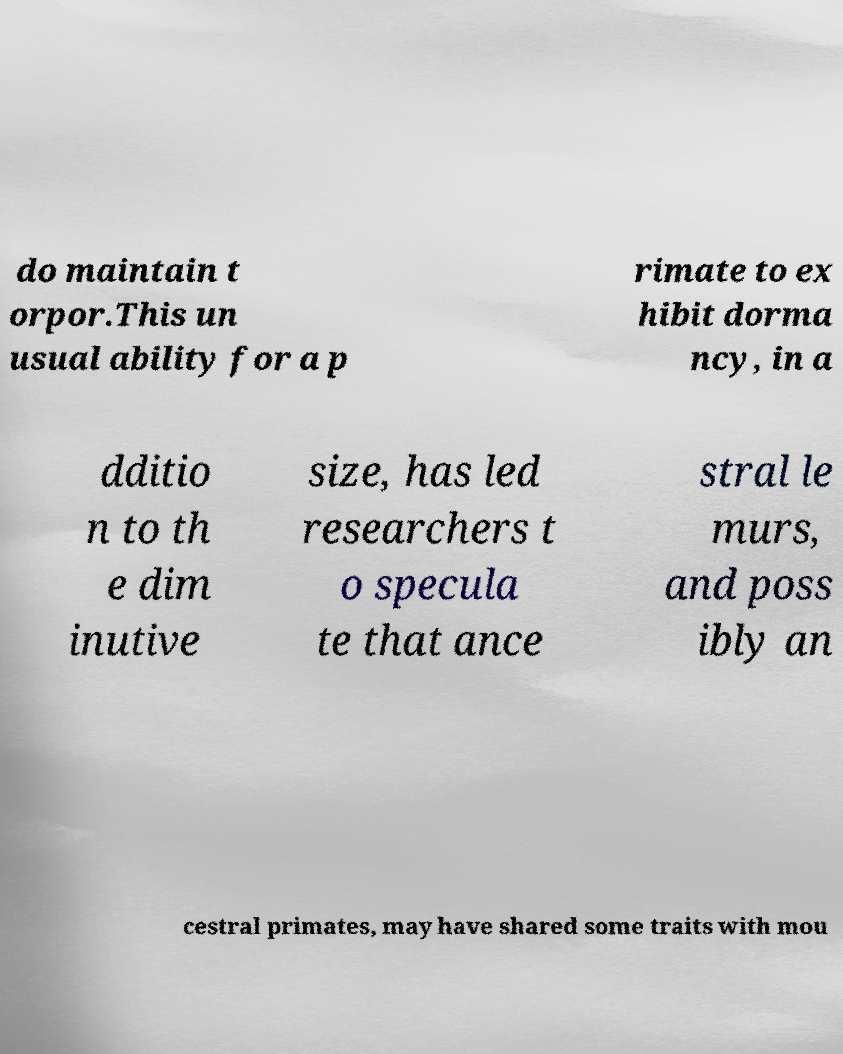What messages or text are displayed in this image? I need them in a readable, typed format. do maintain t orpor.This un usual ability for a p rimate to ex hibit dorma ncy, in a dditio n to th e dim inutive size, has led researchers t o specula te that ance stral le murs, and poss ibly an cestral primates, may have shared some traits with mou 